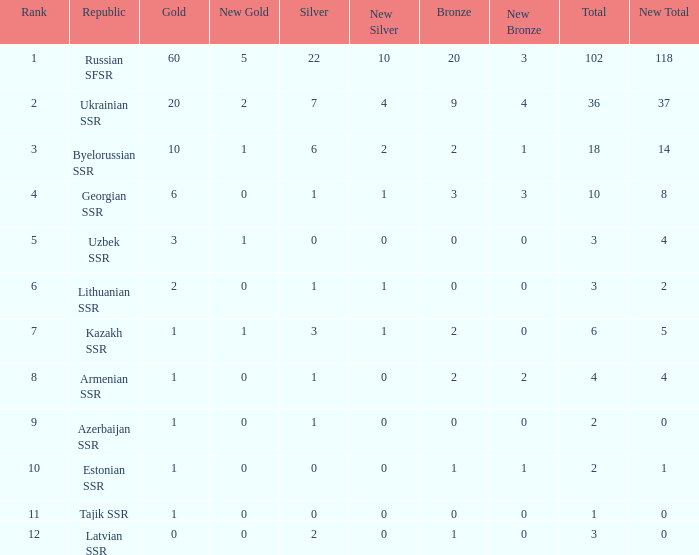What is the sum of silvers for teams with ranks over 3 and totals under 2? 0.0. 